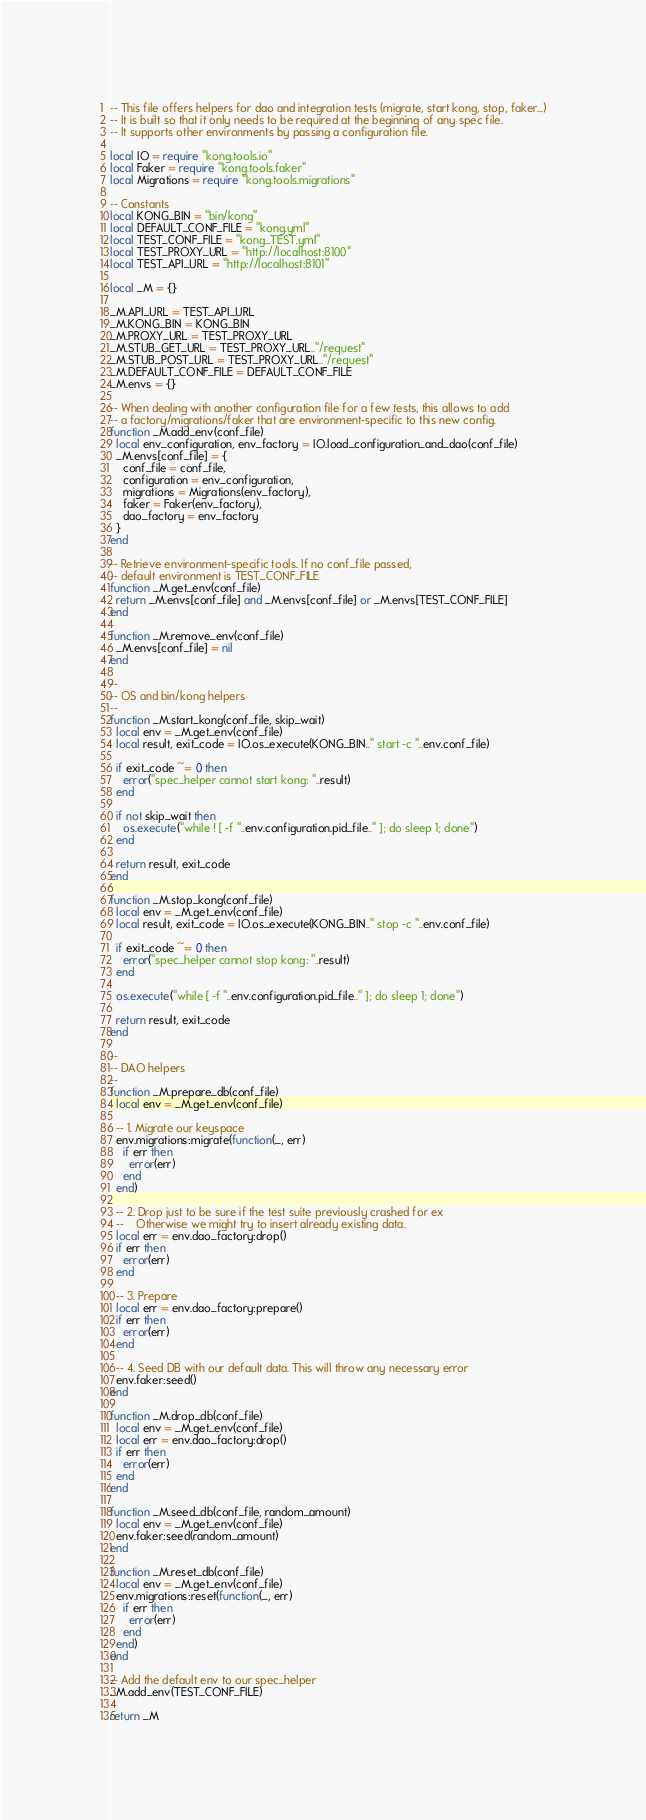<code> <loc_0><loc_0><loc_500><loc_500><_Lua_>-- This file offers helpers for dao and integration tests (migrate, start kong, stop, faker...)
-- It is built so that it only needs to be required at the beginning of any spec file.
-- It supports other environments by passing a configuration file.

local IO = require "kong.tools.io"
local Faker = require "kong.tools.faker"
local Migrations = require "kong.tools.migrations"

-- Constants
local KONG_BIN = "bin/kong"
local DEFAULT_CONF_FILE = "kong.yml"
local TEST_CONF_FILE = "kong_TEST.yml"
local TEST_PROXY_URL = "http://localhost:8100"
local TEST_API_URL = "http://localhost:8101"

local _M = {}

_M.API_URL = TEST_API_URL
_M.KONG_BIN = KONG_BIN
_M.PROXY_URL = TEST_PROXY_URL
_M.STUB_GET_URL = TEST_PROXY_URL.."/request"
_M.STUB_POST_URL = TEST_PROXY_URL.."/request"
_M.DEFAULT_CONF_FILE = DEFAULT_CONF_FILE
_M.envs = {}

-- When dealing with another configuration file for a few tests, this allows to add
-- a factory/migrations/faker that are environment-specific to this new config.
function _M.add_env(conf_file)
  local env_configuration, env_factory = IO.load_configuration_and_dao(conf_file)
  _M.envs[conf_file] = {
    conf_file = conf_file,
    configuration = env_configuration,
    migrations = Migrations(env_factory),
    faker = Faker(env_factory),
    dao_factory = env_factory
  }
end

-- Retrieve environment-specific tools. If no conf_file passed,
-- default environment is TEST_CONF_FILE
function _M.get_env(conf_file)
  return _M.envs[conf_file] and _M.envs[conf_file] or _M.envs[TEST_CONF_FILE]
end

function _M.remove_env(conf_file)
  _M.envs[conf_file] = nil
end

--
-- OS and bin/kong helpers
--
function _M.start_kong(conf_file, skip_wait)
  local env = _M.get_env(conf_file)
  local result, exit_code = IO.os_execute(KONG_BIN.." start -c "..env.conf_file)

  if exit_code ~= 0 then
    error("spec_helper cannot start kong: "..result)
  end

  if not skip_wait then
    os.execute("while ! [ -f "..env.configuration.pid_file.." ]; do sleep 1; done")
  end

  return result, exit_code
end

function _M.stop_kong(conf_file)
  local env = _M.get_env(conf_file)
  local result, exit_code = IO.os_execute(KONG_BIN.." stop -c "..env.conf_file)

  if exit_code ~= 0 then
    error("spec_helper cannot stop kong: "..result)
  end

  os.execute("while [ -f "..env.configuration.pid_file.." ]; do sleep 1; done")

  return result, exit_code
end

--
-- DAO helpers
--
function _M.prepare_db(conf_file)
  local env = _M.get_env(conf_file)

  -- 1. Migrate our keyspace
  env.migrations:migrate(function(_, err)
    if err then
      error(err)
    end
  end)

  -- 2. Drop just to be sure if the test suite previously crashed for ex
  --    Otherwise we might try to insert already existing data.
  local err = env.dao_factory:drop()
  if err then
    error(err)
  end

  -- 3. Prepare
  local err = env.dao_factory:prepare()
  if err then
    error(err)
  end

  -- 4. Seed DB with our default data. This will throw any necessary error
  env.faker:seed()
end

function _M.drop_db(conf_file)
  local env = _M.get_env(conf_file)
  local err = env.dao_factory:drop()
  if err then
    error(err)
  end
end

function _M.seed_db(conf_file, random_amount)
  local env = _M.get_env(conf_file)
  env.faker:seed(random_amount)
end

function _M.reset_db(conf_file)
  local env = _M.get_env(conf_file)
  env.migrations:reset(function(_, err)
    if err then
      error(err)
    end
  end)
end

-- Add the default env to our spec_helper
_M.add_env(TEST_CONF_FILE)

return _M
</code> 